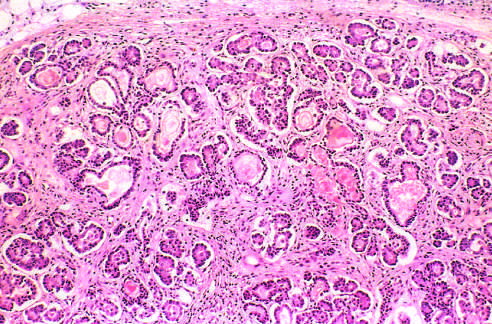how are the parenchymal glands?
Answer the question using a single word or phrase. Atrophic and replaced by fibrous tissue 